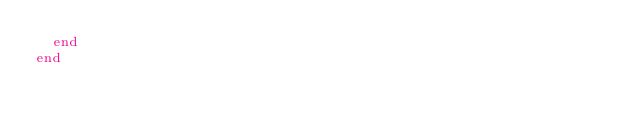Convert code to text. <code><loc_0><loc_0><loc_500><loc_500><_Ruby_>  end
end
</code> 